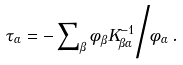Convert formula to latex. <formula><loc_0><loc_0><loc_500><loc_500>\tau _ { \alpha } = - \sum \nolimits _ { \beta } \phi _ { \beta } K ^ { - 1 } _ { \beta \alpha } \Big / \phi _ { \alpha } \, .</formula> 